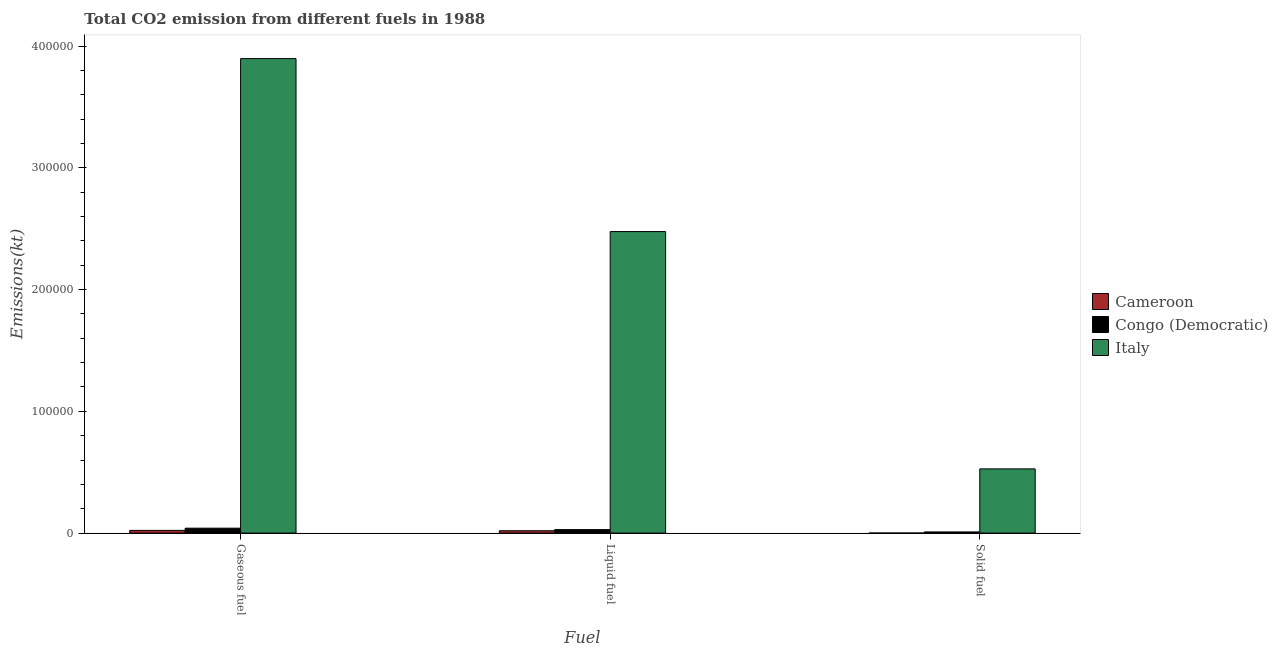How many different coloured bars are there?
Your response must be concise. 3. How many groups of bars are there?
Your answer should be compact. 3. What is the label of the 1st group of bars from the left?
Your response must be concise. Gaseous fuel. What is the amount of co2 emissions from liquid fuel in Congo (Democratic)?
Provide a short and direct response. 2841.93. Across all countries, what is the maximum amount of co2 emissions from liquid fuel?
Your answer should be very brief. 2.48e+05. Across all countries, what is the minimum amount of co2 emissions from liquid fuel?
Your answer should be compact. 1917.84. In which country was the amount of co2 emissions from gaseous fuel minimum?
Give a very brief answer. Cameroon. What is the total amount of co2 emissions from liquid fuel in the graph?
Your answer should be compact. 2.52e+05. What is the difference between the amount of co2 emissions from solid fuel in Italy and that in Congo (Democratic)?
Make the answer very short. 5.18e+04. What is the difference between the amount of co2 emissions from solid fuel in Italy and the amount of co2 emissions from gaseous fuel in Cameroon?
Your answer should be very brief. 5.05e+04. What is the average amount of co2 emissions from solid fuel per country?
Offer a terse response. 1.79e+04. What is the difference between the amount of co2 emissions from gaseous fuel and amount of co2 emissions from solid fuel in Cameroon?
Provide a succinct answer. 2207.53. What is the ratio of the amount of co2 emissions from gaseous fuel in Italy to that in Cameroon?
Offer a terse response. 176.28. What is the difference between the highest and the second highest amount of co2 emissions from gaseous fuel?
Provide a short and direct response. 3.86e+05. What is the difference between the highest and the lowest amount of co2 emissions from solid fuel?
Offer a very short reply. 5.27e+04. In how many countries, is the amount of co2 emissions from gaseous fuel greater than the average amount of co2 emissions from gaseous fuel taken over all countries?
Make the answer very short. 1. What does the 2nd bar from the left in Solid fuel represents?
Provide a succinct answer. Congo (Democratic). What does the 3rd bar from the right in Solid fuel represents?
Your response must be concise. Cameroon. Is it the case that in every country, the sum of the amount of co2 emissions from gaseous fuel and amount of co2 emissions from liquid fuel is greater than the amount of co2 emissions from solid fuel?
Provide a short and direct response. Yes. How many countries are there in the graph?
Your response must be concise. 3. Does the graph contain grids?
Offer a very short reply. No. Where does the legend appear in the graph?
Provide a succinct answer. Center right. How are the legend labels stacked?
Provide a succinct answer. Vertical. What is the title of the graph?
Provide a succinct answer. Total CO2 emission from different fuels in 1988. What is the label or title of the X-axis?
Give a very brief answer. Fuel. What is the label or title of the Y-axis?
Your answer should be compact. Emissions(kt). What is the Emissions(kt) in Cameroon in Gaseous fuel?
Your answer should be compact. 2211.2. What is the Emissions(kt) of Congo (Democratic) in Gaseous fuel?
Provide a succinct answer. 4019.03. What is the Emissions(kt) in Italy in Gaseous fuel?
Provide a succinct answer. 3.90e+05. What is the Emissions(kt) of Cameroon in Liquid fuel?
Offer a terse response. 1917.84. What is the Emissions(kt) in Congo (Democratic) in Liquid fuel?
Keep it short and to the point. 2841.93. What is the Emissions(kt) of Italy in Liquid fuel?
Ensure brevity in your answer.  2.48e+05. What is the Emissions(kt) in Cameroon in Solid fuel?
Offer a very short reply. 3.67. What is the Emissions(kt) in Congo (Democratic) in Solid fuel?
Ensure brevity in your answer.  931.42. What is the Emissions(kt) of Italy in Solid fuel?
Your answer should be very brief. 5.27e+04. Across all Fuel, what is the maximum Emissions(kt) of Cameroon?
Your answer should be very brief. 2211.2. Across all Fuel, what is the maximum Emissions(kt) in Congo (Democratic)?
Provide a succinct answer. 4019.03. Across all Fuel, what is the maximum Emissions(kt) in Italy?
Provide a succinct answer. 3.90e+05. Across all Fuel, what is the minimum Emissions(kt) in Cameroon?
Provide a succinct answer. 3.67. Across all Fuel, what is the minimum Emissions(kt) in Congo (Democratic)?
Your response must be concise. 931.42. Across all Fuel, what is the minimum Emissions(kt) of Italy?
Your answer should be compact. 5.27e+04. What is the total Emissions(kt) of Cameroon in the graph?
Provide a succinct answer. 4132.71. What is the total Emissions(kt) of Congo (Democratic) in the graph?
Make the answer very short. 7792.38. What is the total Emissions(kt) in Italy in the graph?
Your answer should be compact. 6.90e+05. What is the difference between the Emissions(kt) in Cameroon in Gaseous fuel and that in Liquid fuel?
Provide a succinct answer. 293.36. What is the difference between the Emissions(kt) of Congo (Democratic) in Gaseous fuel and that in Liquid fuel?
Make the answer very short. 1177.11. What is the difference between the Emissions(kt) of Italy in Gaseous fuel and that in Liquid fuel?
Offer a terse response. 1.42e+05. What is the difference between the Emissions(kt) of Cameroon in Gaseous fuel and that in Solid fuel?
Ensure brevity in your answer.  2207.53. What is the difference between the Emissions(kt) in Congo (Democratic) in Gaseous fuel and that in Solid fuel?
Give a very brief answer. 3087.61. What is the difference between the Emissions(kt) in Italy in Gaseous fuel and that in Solid fuel?
Give a very brief answer. 3.37e+05. What is the difference between the Emissions(kt) in Cameroon in Liquid fuel and that in Solid fuel?
Your answer should be very brief. 1914.17. What is the difference between the Emissions(kt) in Congo (Democratic) in Liquid fuel and that in Solid fuel?
Offer a terse response. 1910.51. What is the difference between the Emissions(kt) in Italy in Liquid fuel and that in Solid fuel?
Your answer should be compact. 1.95e+05. What is the difference between the Emissions(kt) of Cameroon in Gaseous fuel and the Emissions(kt) of Congo (Democratic) in Liquid fuel?
Ensure brevity in your answer.  -630.72. What is the difference between the Emissions(kt) of Cameroon in Gaseous fuel and the Emissions(kt) of Italy in Liquid fuel?
Make the answer very short. -2.45e+05. What is the difference between the Emissions(kt) in Congo (Democratic) in Gaseous fuel and the Emissions(kt) in Italy in Liquid fuel?
Provide a succinct answer. -2.44e+05. What is the difference between the Emissions(kt) of Cameroon in Gaseous fuel and the Emissions(kt) of Congo (Democratic) in Solid fuel?
Your answer should be compact. 1279.78. What is the difference between the Emissions(kt) of Cameroon in Gaseous fuel and the Emissions(kt) of Italy in Solid fuel?
Ensure brevity in your answer.  -5.05e+04. What is the difference between the Emissions(kt) in Congo (Democratic) in Gaseous fuel and the Emissions(kt) in Italy in Solid fuel?
Your answer should be very brief. -4.87e+04. What is the difference between the Emissions(kt) in Cameroon in Liquid fuel and the Emissions(kt) in Congo (Democratic) in Solid fuel?
Your answer should be compact. 986.42. What is the difference between the Emissions(kt) in Cameroon in Liquid fuel and the Emissions(kt) in Italy in Solid fuel?
Provide a short and direct response. -5.08e+04. What is the difference between the Emissions(kt) in Congo (Democratic) in Liquid fuel and the Emissions(kt) in Italy in Solid fuel?
Offer a terse response. -4.99e+04. What is the average Emissions(kt) of Cameroon per Fuel?
Ensure brevity in your answer.  1377.57. What is the average Emissions(kt) in Congo (Democratic) per Fuel?
Make the answer very short. 2597.46. What is the average Emissions(kt) in Italy per Fuel?
Give a very brief answer. 2.30e+05. What is the difference between the Emissions(kt) in Cameroon and Emissions(kt) in Congo (Democratic) in Gaseous fuel?
Make the answer very short. -1807.83. What is the difference between the Emissions(kt) of Cameroon and Emissions(kt) of Italy in Gaseous fuel?
Provide a short and direct response. -3.88e+05. What is the difference between the Emissions(kt) in Congo (Democratic) and Emissions(kt) in Italy in Gaseous fuel?
Give a very brief answer. -3.86e+05. What is the difference between the Emissions(kt) of Cameroon and Emissions(kt) of Congo (Democratic) in Liquid fuel?
Your answer should be very brief. -924.08. What is the difference between the Emissions(kt) in Cameroon and Emissions(kt) in Italy in Liquid fuel?
Provide a short and direct response. -2.46e+05. What is the difference between the Emissions(kt) of Congo (Democratic) and Emissions(kt) of Italy in Liquid fuel?
Offer a very short reply. -2.45e+05. What is the difference between the Emissions(kt) in Cameroon and Emissions(kt) in Congo (Democratic) in Solid fuel?
Your answer should be very brief. -927.75. What is the difference between the Emissions(kt) of Cameroon and Emissions(kt) of Italy in Solid fuel?
Keep it short and to the point. -5.27e+04. What is the difference between the Emissions(kt) in Congo (Democratic) and Emissions(kt) in Italy in Solid fuel?
Offer a very short reply. -5.18e+04. What is the ratio of the Emissions(kt) of Cameroon in Gaseous fuel to that in Liquid fuel?
Ensure brevity in your answer.  1.15. What is the ratio of the Emissions(kt) of Congo (Democratic) in Gaseous fuel to that in Liquid fuel?
Provide a succinct answer. 1.41. What is the ratio of the Emissions(kt) of Italy in Gaseous fuel to that in Liquid fuel?
Offer a terse response. 1.57. What is the ratio of the Emissions(kt) in Cameroon in Gaseous fuel to that in Solid fuel?
Your answer should be compact. 603. What is the ratio of the Emissions(kt) of Congo (Democratic) in Gaseous fuel to that in Solid fuel?
Keep it short and to the point. 4.32. What is the ratio of the Emissions(kt) in Italy in Gaseous fuel to that in Solid fuel?
Your response must be concise. 7.39. What is the ratio of the Emissions(kt) in Cameroon in Liquid fuel to that in Solid fuel?
Ensure brevity in your answer.  523. What is the ratio of the Emissions(kt) of Congo (Democratic) in Liquid fuel to that in Solid fuel?
Make the answer very short. 3.05. What is the ratio of the Emissions(kt) in Italy in Liquid fuel to that in Solid fuel?
Give a very brief answer. 4.7. What is the difference between the highest and the second highest Emissions(kt) of Cameroon?
Offer a very short reply. 293.36. What is the difference between the highest and the second highest Emissions(kt) in Congo (Democratic)?
Your response must be concise. 1177.11. What is the difference between the highest and the second highest Emissions(kt) in Italy?
Offer a terse response. 1.42e+05. What is the difference between the highest and the lowest Emissions(kt) of Cameroon?
Provide a short and direct response. 2207.53. What is the difference between the highest and the lowest Emissions(kt) in Congo (Democratic)?
Provide a short and direct response. 3087.61. What is the difference between the highest and the lowest Emissions(kt) in Italy?
Your answer should be compact. 3.37e+05. 